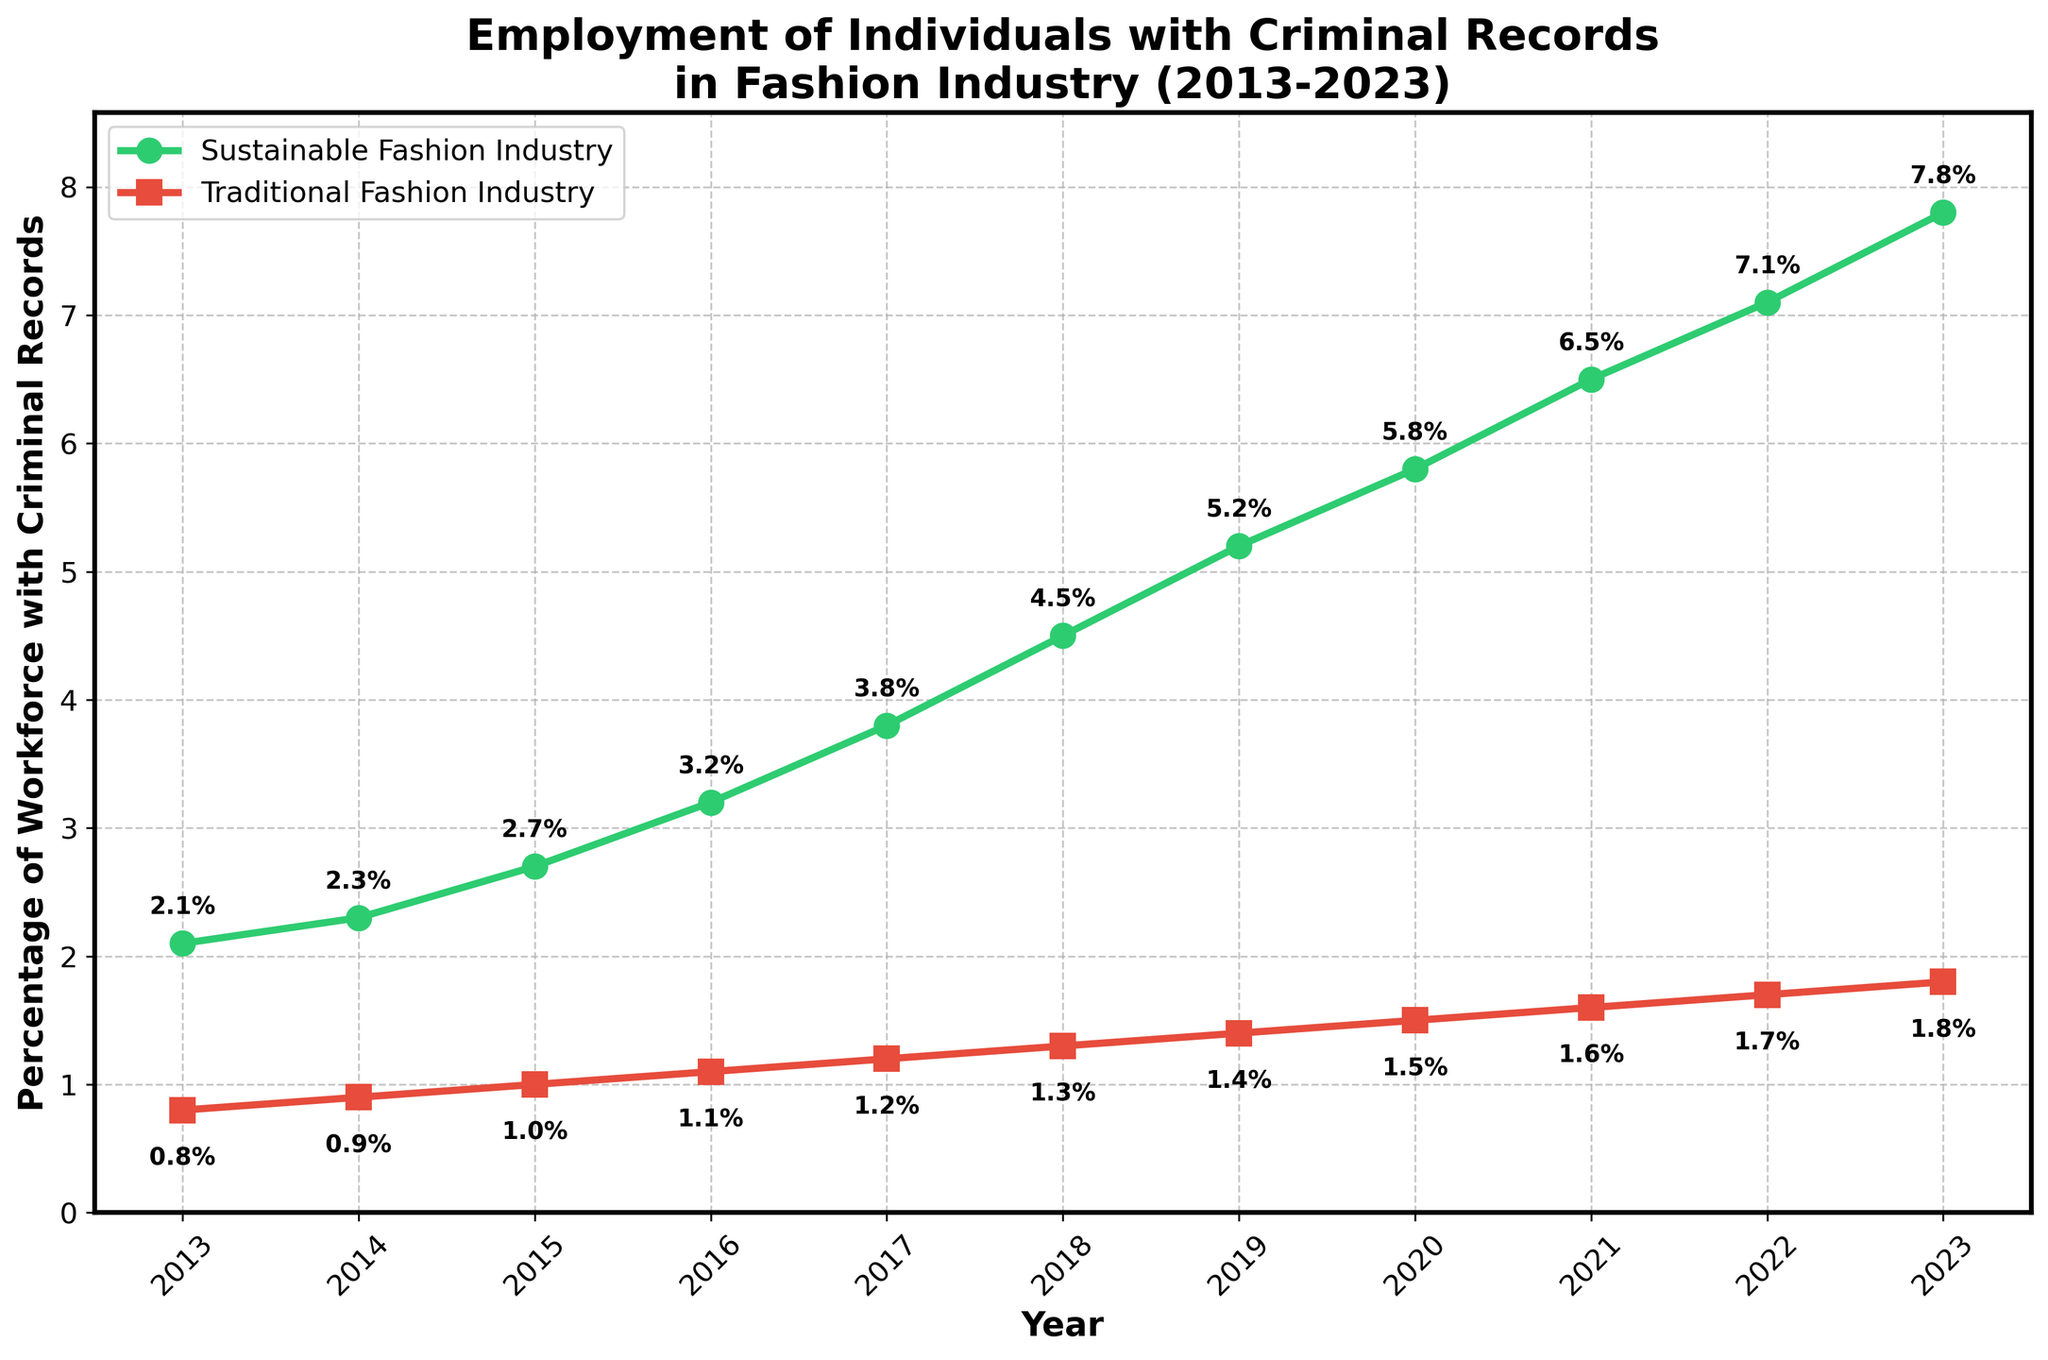What's the overall trend in the percentage of workforce with criminal records in the sustainable fashion industry from 2013 to 2023? Look at the green line representing the sustainable fashion industry. It starts at 2.1% in 2013 and increases to 7.8% in 2023. This indicates a consistent upward trend over the years.
Answer: Consistent upward trend How does the 2023 percentage of workforce with criminal records compare between sustainable and traditional fashion industries? In the chart, the percentage for 2023 in the sustainable fashion industry is 7.8%, while for the traditional fashion industry it's 1.8%. Therefore, the sustainable fashion industry has a higher percentage.
Answer: Higher in sustainable fashion industry What's the percentage increase of the workforce with criminal records in the sustainable fashion industry from 2013 to 2023? First, find the difference between the 2023 (7.8%) and 2013 (2.1%) values in the sustainable fashion industry. The percentage increase is 7.8% - 2.1% = 5.7%.
Answer: 5.7% In which year did the sustainable fashion industry surpass 5% for the first time? Looking at the green line in the chart, the sustainable fashion industry surpasses 5% between 2018 (4.5%) and 2019 (5.2%). Therefore, it first surpasses 5% in 2019.
Answer: 2019 By how much percentage did the traditional fashion industry's workforce with criminal records increase from 2013 to 2023? Check the chart for the traditional fashion industry values. The percentage increases from 0.8% in 2013 to 1.8% in 2023. The increase is 1.8% - 0.8% = 1%.
Answer: 1% What is the difference in the percentage of workforce with criminal records between the two industries in 2020? For 2020, the sustainable fashion industry is at 5.8% while the traditional fashion industry is at 1.5%. The difference is 5.8% - 1.5% = 4.3%.
Answer: 4.3% Which year shows the highest percentage increase for the sustainable fashion industry compared to the previous year? Calculate the yearly increase in the sustainable fashion industry by subtracting the percentage of the previous year for each year. The highest increase is between 2017 (3.8%) and 2018 (4.5%), which is 4.5% - 3.8% = 0.7%.
Answer: 2018 What visual cues indicate the fastest growth sector in the chart? The green line representing the sustainable fashion industry has a steeper upward slope compared to the red line of the traditional fashion industry over the same period, indicating faster growth.
Answer: Steeper slope of the green line What were the percentages of workers with criminal records in both industries in 2017? Refer to the specific year values in the chart: for 2017, the sustainable fashion industry is 3.8% and the traditional fashion industry is 1.2%.
Answer: 3.8% and 1.2% How did the percentage difference between the two industries' workforce with criminal records evolve from 2013 to 2023? Begin with the percentage difference in 2013 (2.1% - 0.8% = 1.3%). Examine subsequent differences each year and see a growing trend, reaching 7.8% - 1.8% = 6% in 2023. Thus, the difference increased over time.
Answer: Increased over time 